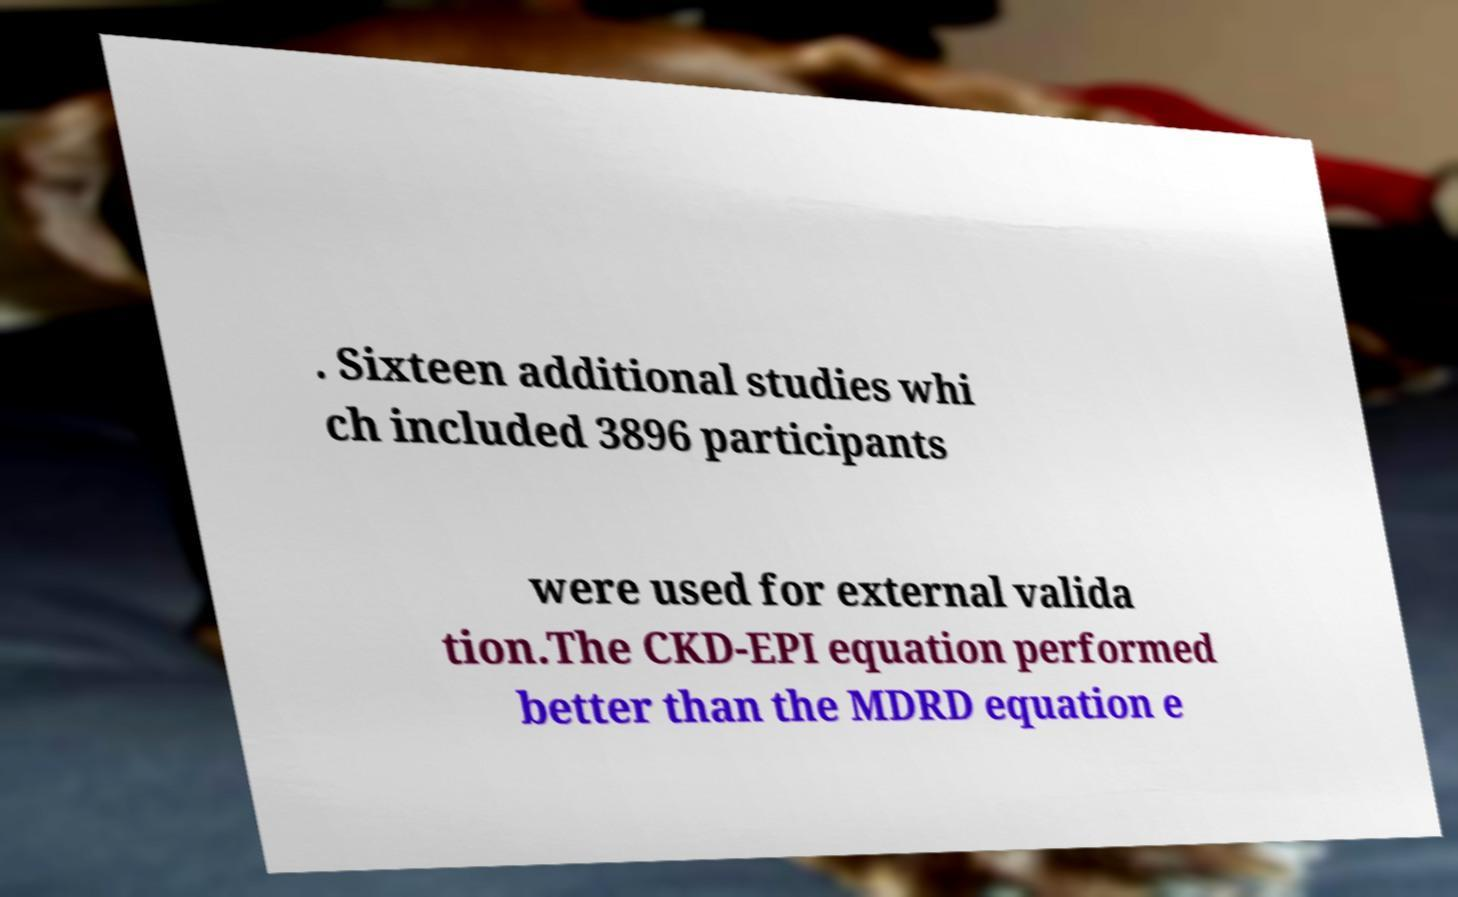Please read and relay the text visible in this image. What does it say? . Sixteen additional studies whi ch included 3896 participants were used for external valida tion.The CKD-EPI equation performed better than the MDRD equation e 